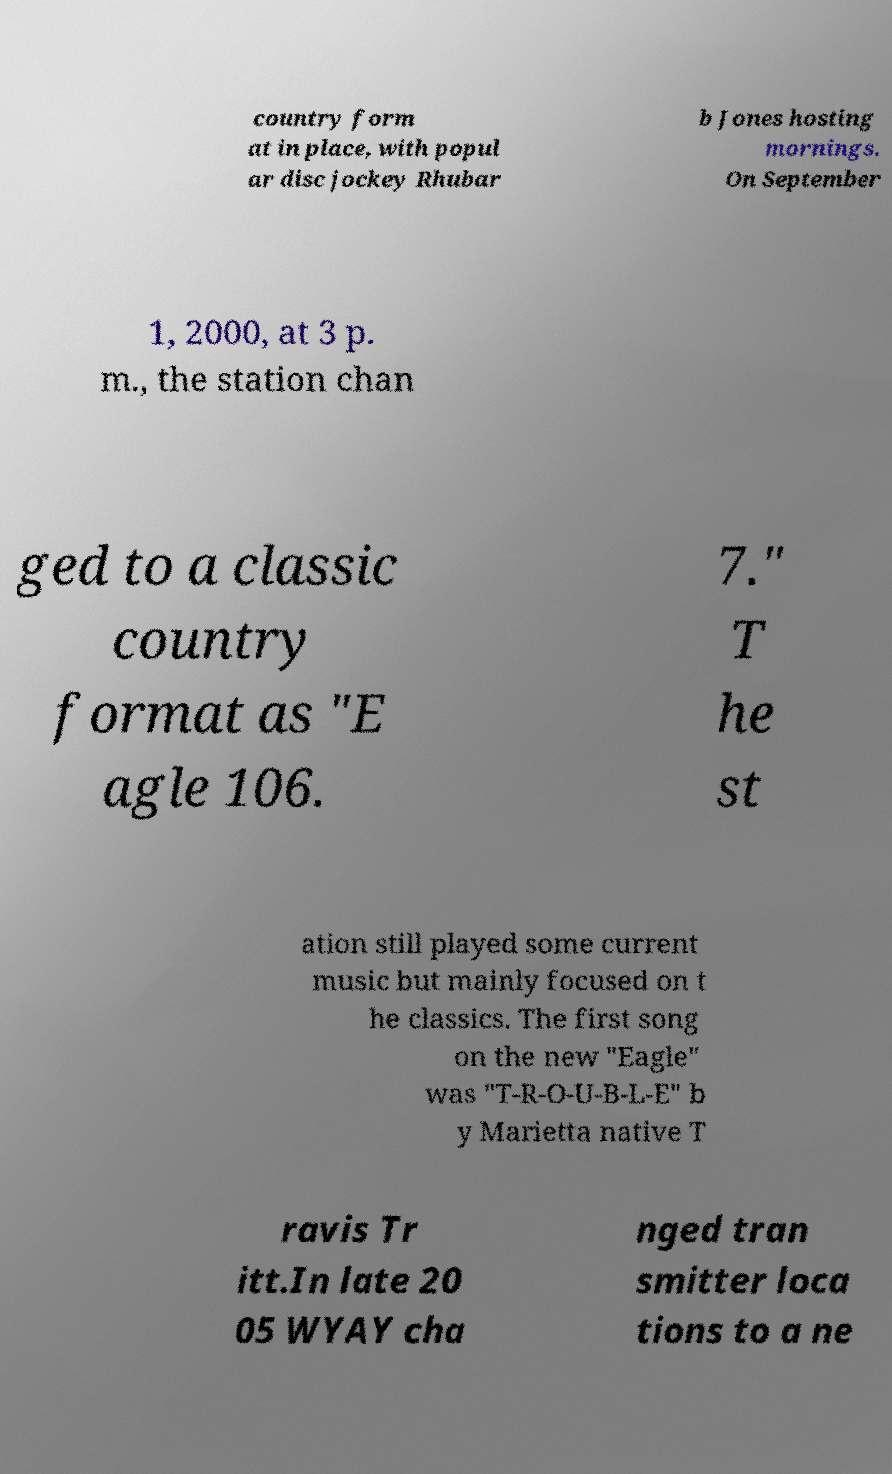Can you accurately transcribe the text from the provided image for me? country form at in place, with popul ar disc jockey Rhubar b Jones hosting mornings. On September 1, 2000, at 3 p. m., the station chan ged to a classic country format as "E agle 106. 7." T he st ation still played some current music but mainly focused on t he classics. The first song on the new "Eagle" was "T-R-O-U-B-L-E" b y Marietta native T ravis Tr itt.In late 20 05 WYAY cha nged tran smitter loca tions to a ne 